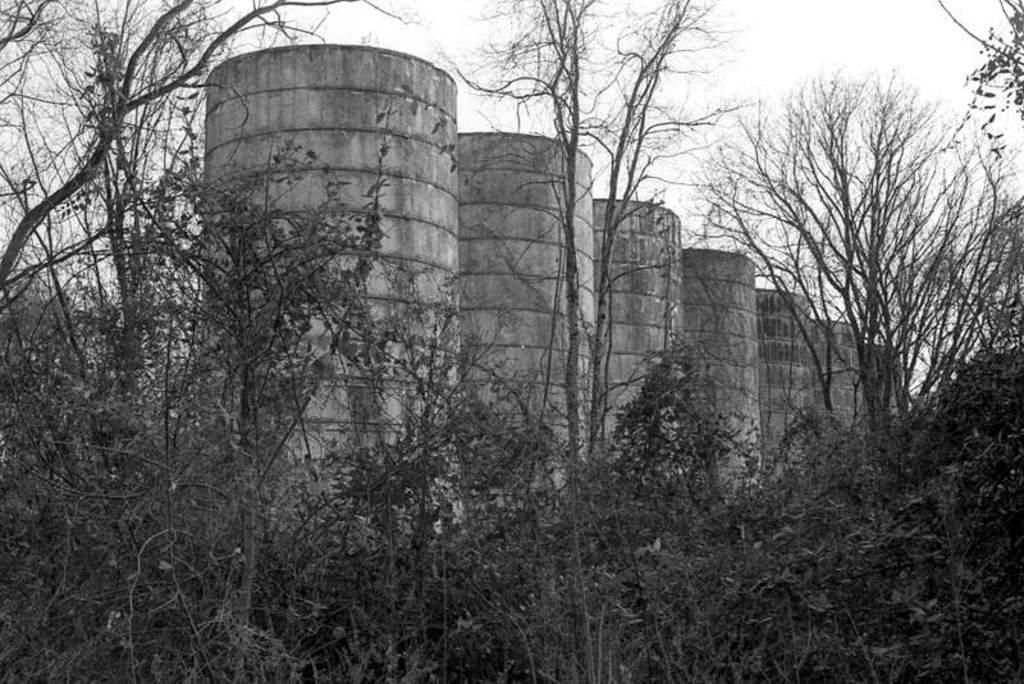What type of vegetation can be seen in the image? There are plants and trees in the image. What architectural features are present in the image? There are pillars in the image. What is visible in the background of the image? The sky is visible in the background of the image. What type of wax can be seen dripping from the trees in the image? There is no wax present in the image; it features plants, trees, pillars, and the sky. How many cakes are visible on the branches of the trees in the image? There are no cakes present in the image; it features plants, trees, pillars, and the sky. 